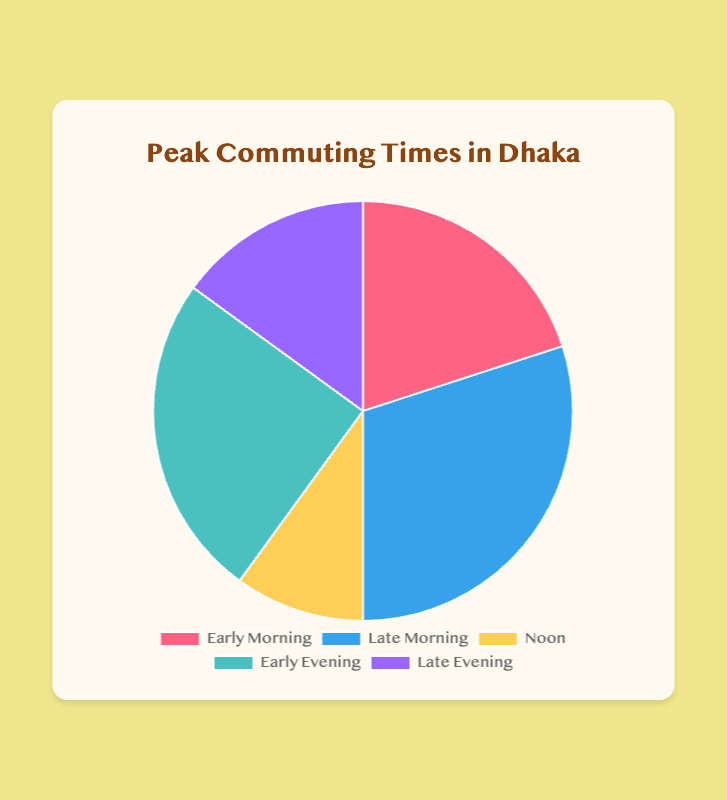What percentage of commuters travel in the early morning? According to the data, the 'Early Morning' segment corresponds to 20% of commuters.
Answer: 20% Which time period has the highest percentage of commuters? By comparing all the time periods, 'Late Morning' has the highest percentage of commuters at 30%.
Answer: Late Morning What is the difference in commuter percentages between the Early Morning and Late Evening periods? The commuter percentage for Early Morning is 20% and for Late Evening is 15%. The difference is 20% - 15% = 5%.
Answer: 5% What is the total percentage of commuters during the Morning periods (Early and Late)? Adding the commuter percentages for Early Morning (20%) and Late Morning (30%) gives 20% + 30% = 50%.
Answer: 50% Is the percentage of commuters at Noon higher or lower than 20%? The commuter percentage at Noon is 10%, which is lower than 20%.
Answer: Lower How much higher is the percentage of commuters in Early Evening compared to Noon? The percentages are 25% for Early Evening and 10% for Noon. The difference is 25% - 10% = 15%.
Answer: 15% If I usually commute in the Early Evening, what percentage of commuters travel at the same time? According to the data, the percentage of commuters in Early Evening is 25%.
Answer: 25% What are the two time periods with the least percentage of commuters? By reviewing the data, 'Noon' with 10% and 'Late Evening' with 15% have the least percentage of commuters.
Answer: Noon and Late Evening What's the combined percentage of commuters during the Evening periods (Early and Late)? Adding the commuter percentages for Early Evening (25%) and Late Evening (15%) gives 25% + 15% = 40%.
Answer: 40% Which color represents the commuter percentage at Noon? The 'Noon' segment is represented by the yellow color in the pie chart.
Answer: Yellow 